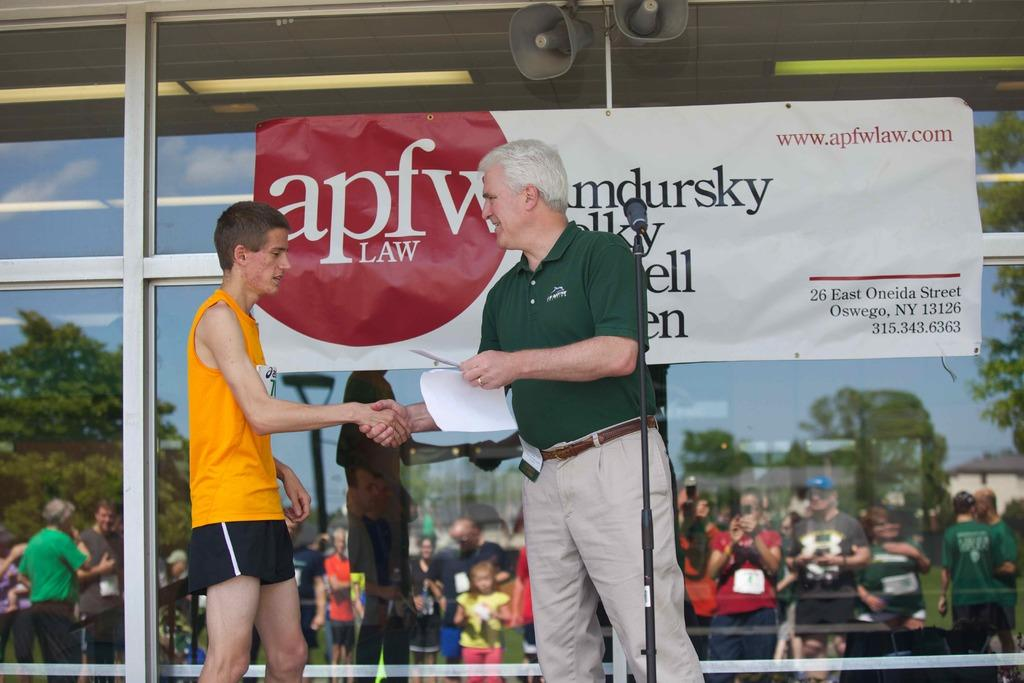<image>
Share a concise interpretation of the image provided. the letters apfw that are on a sign 